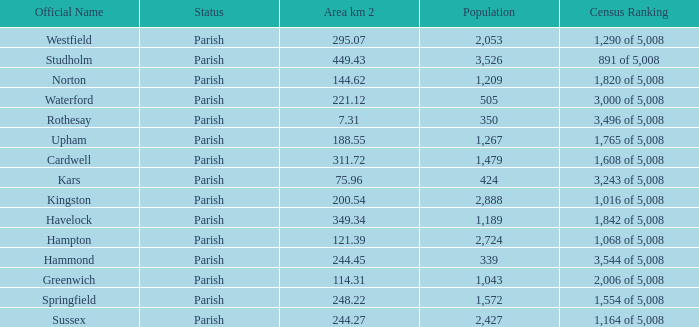Would you be able to parse every entry in this table? {'header': ['Official Name', 'Status', 'Area km 2', 'Population', 'Census Ranking'], 'rows': [['Westfield', 'Parish', '295.07', '2,053', '1,290 of 5,008'], ['Studholm', 'Parish', '449.43', '3,526', '891 of 5,008'], ['Norton', 'Parish', '144.62', '1,209', '1,820 of 5,008'], ['Waterford', 'Parish', '221.12', '505', '3,000 of 5,008'], ['Rothesay', 'Parish', '7.31', '350', '3,496 of 5,008'], ['Upham', 'Parish', '188.55', '1,267', '1,765 of 5,008'], ['Cardwell', 'Parish', '311.72', '1,479', '1,608 of 5,008'], ['Kars', 'Parish', '75.96', '424', '3,243 of 5,008'], ['Kingston', 'Parish', '200.54', '2,888', '1,016 of 5,008'], ['Havelock', 'Parish', '349.34', '1,189', '1,842 of 5,008'], ['Hampton', 'Parish', '121.39', '2,724', '1,068 of 5,008'], ['Hammond', 'Parish', '244.45', '339', '3,544 of 5,008'], ['Greenwich', 'Parish', '114.31', '1,043', '2,006 of 5,008'], ['Springfield', 'Parish', '248.22', '1,572', '1,554 of 5,008'], ['Sussex', 'Parish', '244.27', '2,427', '1,164 of 5,008']]} What is the area in square kilometers of Studholm? 1.0. 